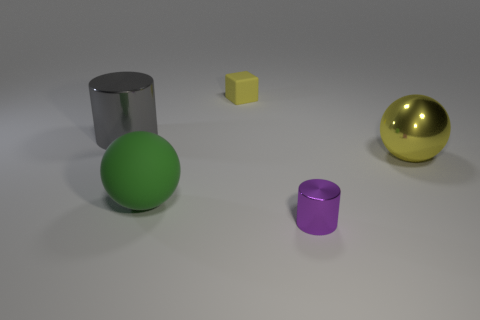What is the size of the shiny sphere that is the same color as the small matte object?
Ensure brevity in your answer.  Large. Do the shiny ball and the small rubber thing have the same color?
Offer a terse response. Yes. Is the number of big brown rubber blocks less than the number of yellow matte cubes?
Give a very brief answer. Yes. How many other things are the same color as the small matte object?
Your answer should be very brief. 1. How many small red cubes are there?
Offer a very short reply. 0. Is the number of metallic objects that are behind the yellow metallic ball less than the number of small things?
Your answer should be compact. Yes. Do the cylinder that is to the right of the large matte object and the large green ball have the same material?
Provide a succinct answer. No. There is a tiny thing to the right of the tiny object that is behind the big thing that is left of the green sphere; what is its shape?
Provide a succinct answer. Cylinder. Are there any purple metallic cylinders of the same size as the green object?
Offer a terse response. No. How big is the purple cylinder?
Provide a short and direct response. Small. 